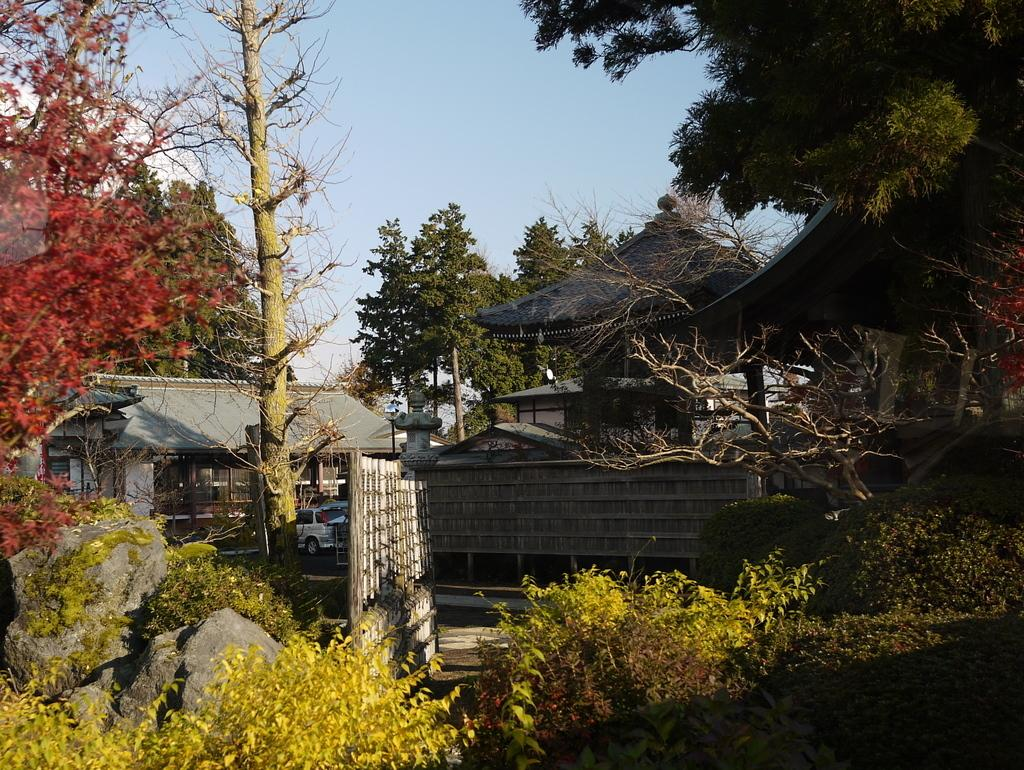What is located in the center of the image? There are houses and cars in the center of the image. What can be seen around the area of the image? There is greenery around the area of the image. What part of the earth is visible in the image? The image does not show a specific part of the earth; it only depicts houses, cars, and greenery. 